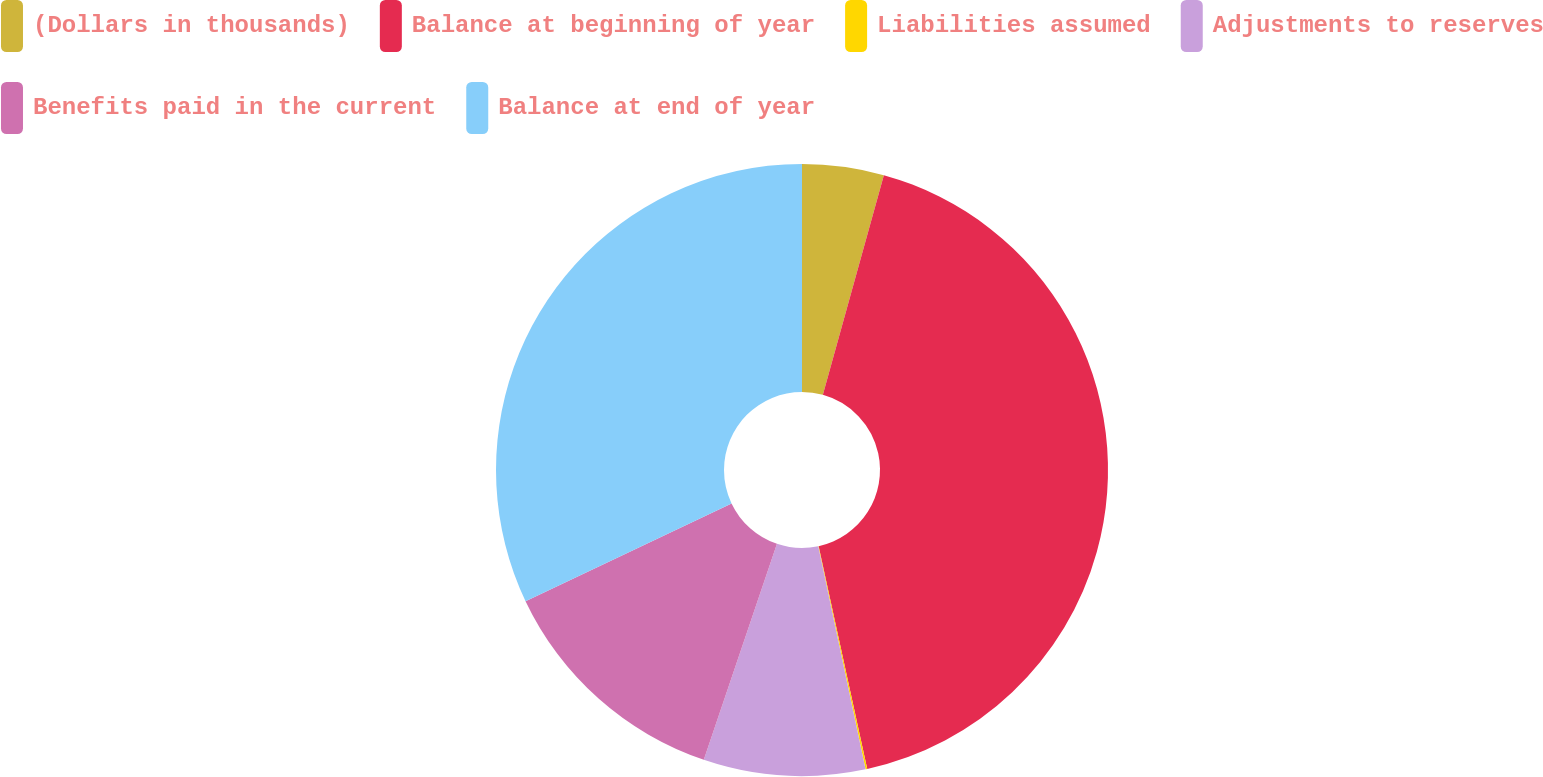<chart> <loc_0><loc_0><loc_500><loc_500><pie_chart><fcel>(Dollars in thousands)<fcel>Balance at beginning of year<fcel>Liabilities assumed<fcel>Adjustments to reserves<fcel>Benefits paid in the current<fcel>Balance at end of year<nl><fcel>4.31%<fcel>42.27%<fcel>0.09%<fcel>8.53%<fcel>12.75%<fcel>32.05%<nl></chart> 